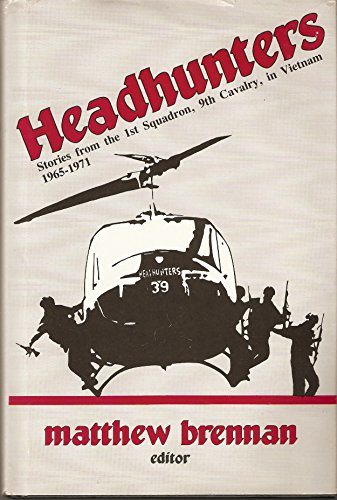Is this book related to Literature & Fiction? No, this book is not related to Literature & Fiction. It is a historical collection, focused on real events and personal stories from the Vietnam War, rather than fictional narratives. 